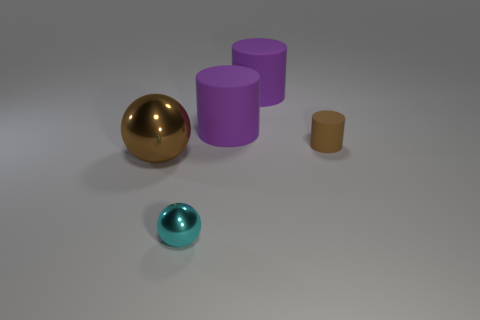Add 2 tiny cyan cubes. How many objects exist? 7 Subtract all purple matte cylinders. How many cylinders are left? 1 Subtract all cylinders. How many objects are left? 2 Subtract 2 cylinders. How many cylinders are left? 1 Subtract all big red metallic cylinders. Subtract all small cylinders. How many objects are left? 4 Add 2 tiny things. How many tiny things are left? 4 Add 1 small cylinders. How many small cylinders exist? 2 Subtract all brown cylinders. How many cylinders are left? 2 Subtract 0 yellow spheres. How many objects are left? 5 Subtract all brown spheres. Subtract all yellow blocks. How many spheres are left? 1 